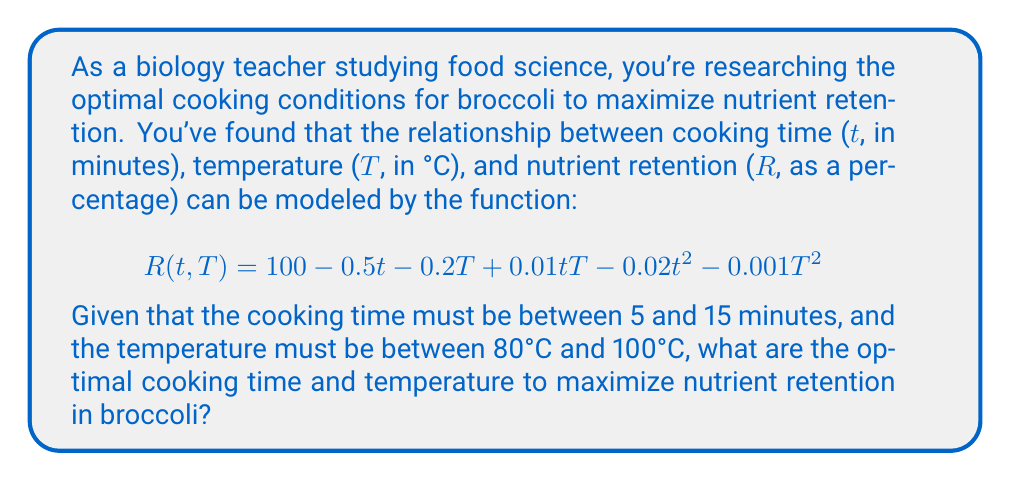Could you help me with this problem? To solve this optimization problem, we need to find the maximum value of the function R(t,T) subject to the given constraints. We can use the method of partial derivatives and the Hessian matrix to find the critical points and determine the maximum.

1. Find the partial derivatives:
   $$\frac{\partial R}{\partial t} = -0.5 + 0.01T - 0.04t$$
   $$\frac{\partial R}{\partial T} = -0.2 + 0.01t - 0.002T$$

2. Set the partial derivatives to zero and solve the system of equations:
   $$-0.5 + 0.01T - 0.04t = 0$$
   $$-0.2 + 0.01t - 0.002T = 0$$

3. Solve the system of equations:
   From the second equation: $T = 100 + 5t$
   Substitute into the first equation:
   $$-0.5 + 0.01(100 + 5t) - 0.04t = 0$$
   $$-0.5 + 1 + 0.05t - 0.04t = 0$$
   $$0.5 + 0.01t = 0$$
   $$t = -50$$

   This critical point is outside our constraints, so we need to check the boundaries.

4. Check the boundaries:
   - t = 5, T = 80: R(5,80) = 87.8
   - t = 5, T = 100: R(5,100) = 85.5
   - t = 15, T = 80: R(15,80) = 80.1
   - t = 15, T = 100: R(15,100) = 82.5

5. Check along the edges:
   - t = 5, 80 ≤ T ≤ 100: Max at T = 80
   - t = 15, 80 ≤ T ≤ 100: Max at T = 100
   - T = 80, 5 ≤ t ≤ 15: Max at t = 5
   - T = 100, 5 ≤ t ≤ 15: Max at t = 5

6. The maximum value occurs at t = 5 minutes and T = 80°C, with R(5,80) = 87.8%.
Answer: The optimal cooking conditions for maximizing nutrient retention in broccoli are a cooking time of 5 minutes at a temperature of 80°C, resulting in 87.8% nutrient retention. 